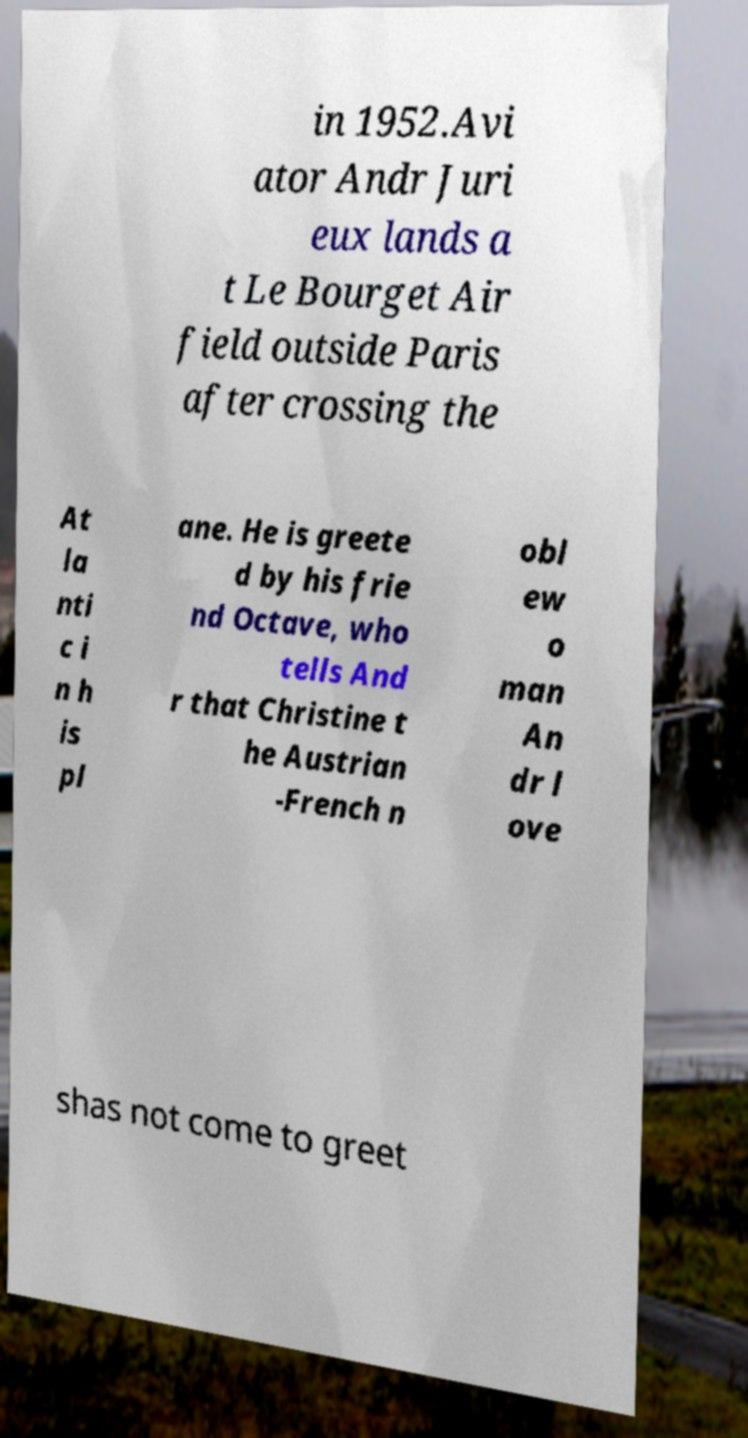Could you extract and type out the text from this image? in 1952.Avi ator Andr Juri eux lands a t Le Bourget Air field outside Paris after crossing the At la nti c i n h is pl ane. He is greete d by his frie nd Octave, who tells And r that Christine t he Austrian -French n obl ew o man An dr l ove shas not come to greet 